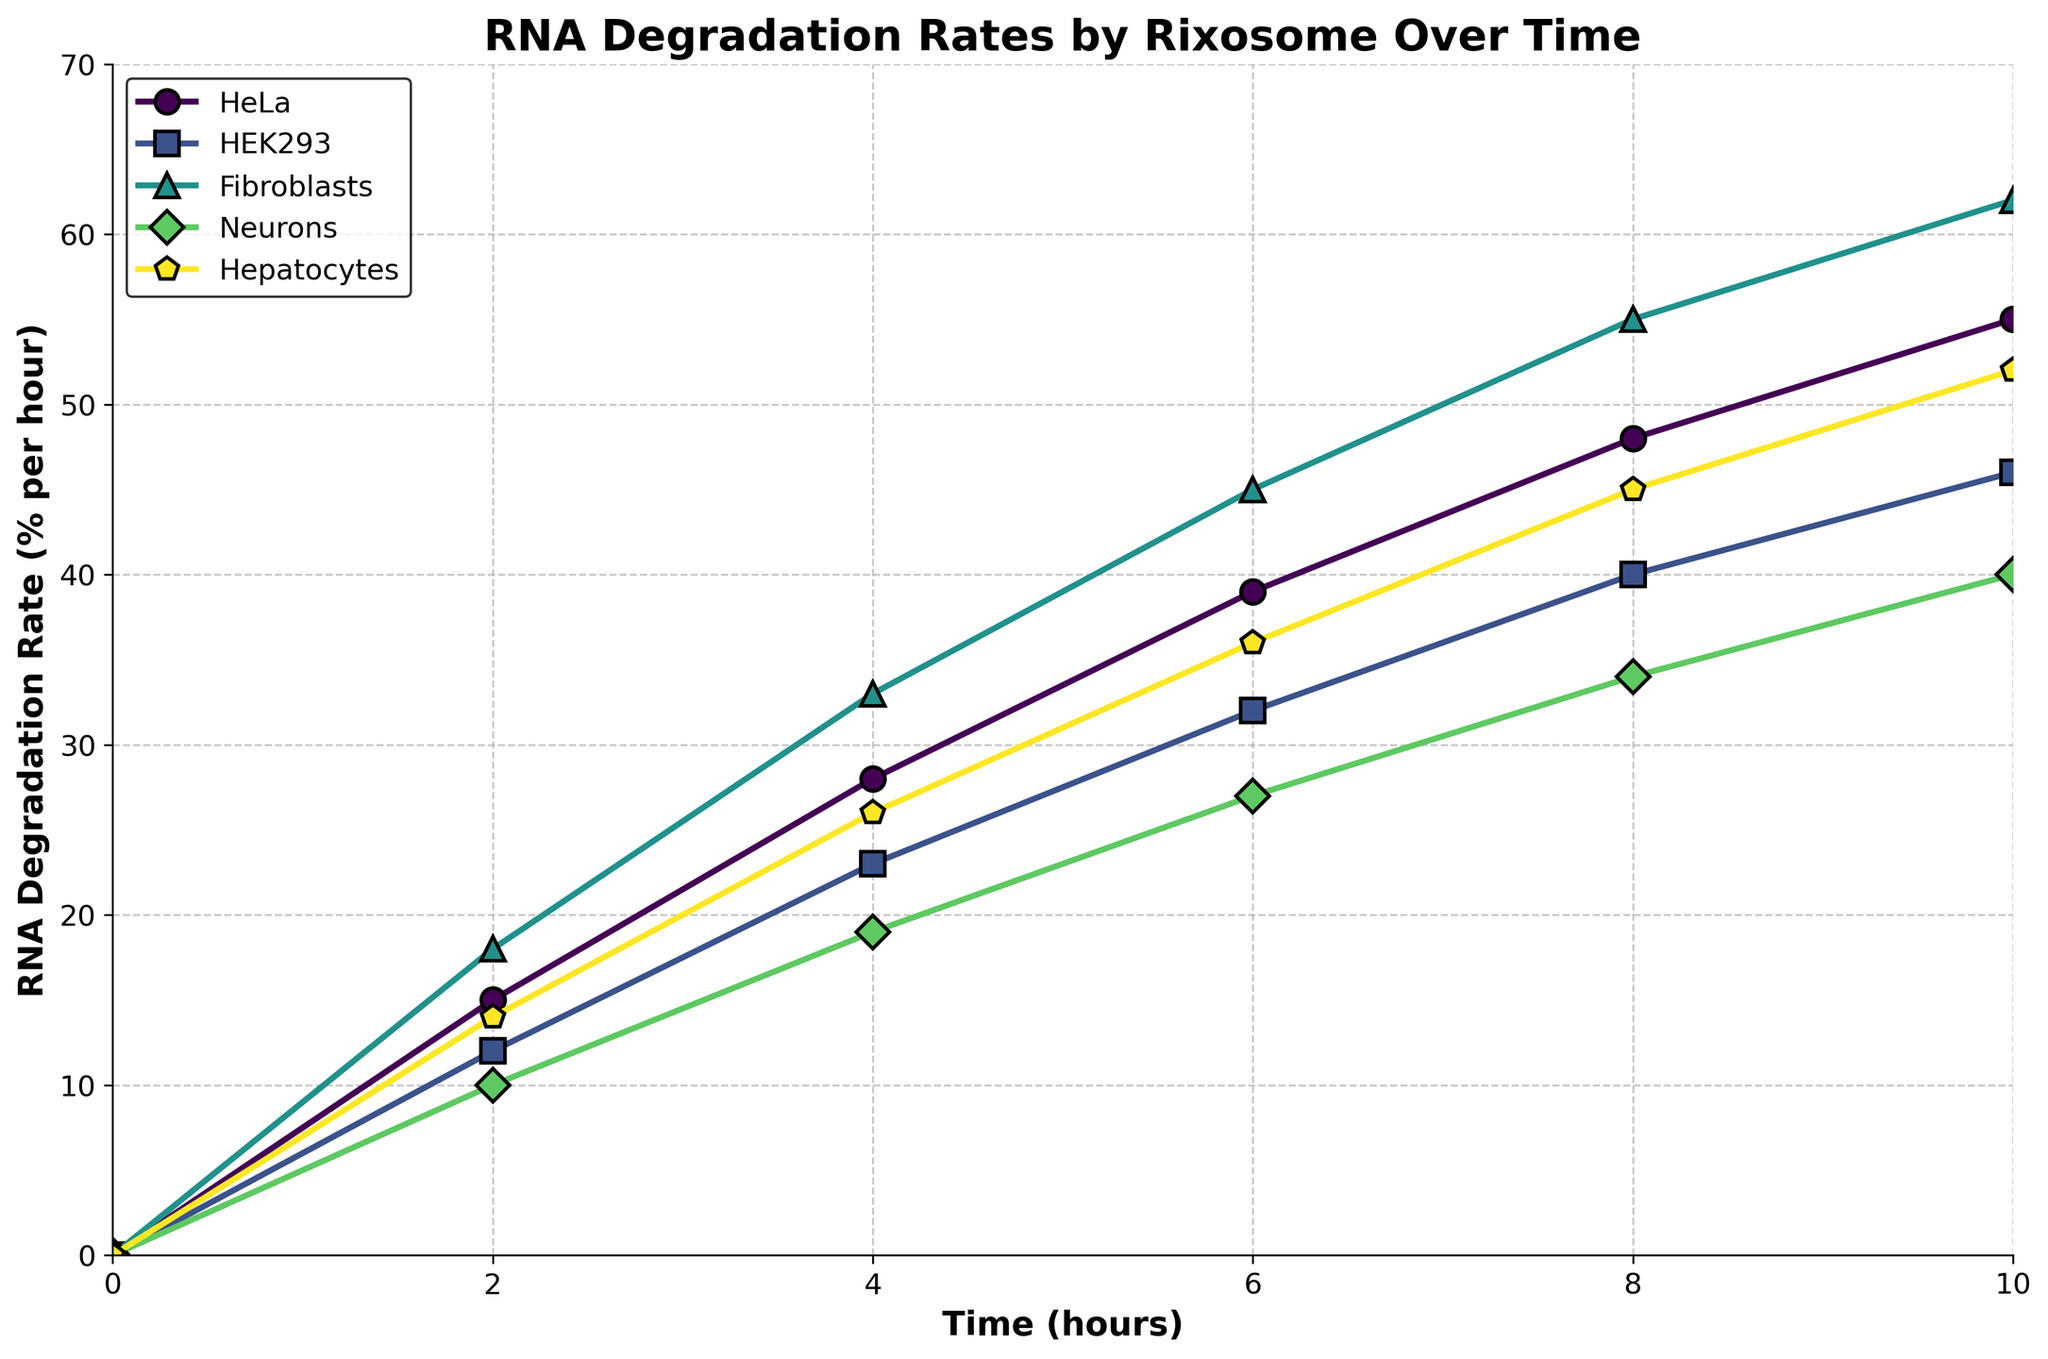How does the RNA degradation rate change over time in HeLa cells? The RNA degradation rate in HeLa cells starts at 0% at 0 hours, increases to 15% at 2 hours, 28% at 4 hours, 39% at 6 hours, 48% at 8 hours, and finally reaches 55% at 10 hours.
Answer: It increases over time Which cell type shows the highest RNA degradation rate at 10 hours? By observing the lines at the 10-hour mark, Fibroblasts show the highest RNA degradation rate with a value of 62%.
Answer: Fibroblasts How do the RNA degradation rates of HeLa and Fibroblasts compare at 6 hours? To compare, HeLa cells have a degradation rate of 39% while Fibroblasts have a rate of 45% at 6 hours. The rate in Fibroblasts is higher.
Answer: Fibroblasts is higher Among the cell types, which one has the lowest RNA degradation rate at 4 hours? At 4 hours, comparing all cell types, the Neurons have the lowest RNA degradation rate of 19%.
Answer: Neurons What is the average RNA degradation rate for HEK293 cells over the entire time period? First, sum up the RNA degradation rates for HEK293 across all time points (0 + 12 + 23 + 32 + 40 + 46 = 153). Then, divide by the number of time points (6). The average is 153/6 = 25.5%.
Answer: 25.5% What color represents the Hepatocytes in the plot? By observing the plot legend, Hepatocytes are represented by a specific color, which in this case is a dark green shade.
Answer: Dark green At 8 hours, which cell type has a higher RNA degradation rate: HeLa or Hepatocytes? At 8 hours, HeLa has a degradation rate of 48%, while Hepatocytes have a rate of 45%. Therefore, HeLa has a slightly higher rate.
Answer: HeLa What is the difference in RNA degradation rates between Neurons and Fibroblasts at 10 hours? At 10 hours, Neurons have a degradation rate of 40%, while Fibroblasts have a rate of 62%. The difference is 62% - 40% = 22%.
Answer: 22% Considering Hepatocytes and HEK293, which cell type shows a more rapid increase in RNA degradation rate from 0 to 10 hours? By comparing the slopes of the lines from 0 to 10 hours, Hepatocytes show a larger increase (52%) compared to HEK293 (46%), indicating a more rapid degradation.
Answer: Hepatocytes 